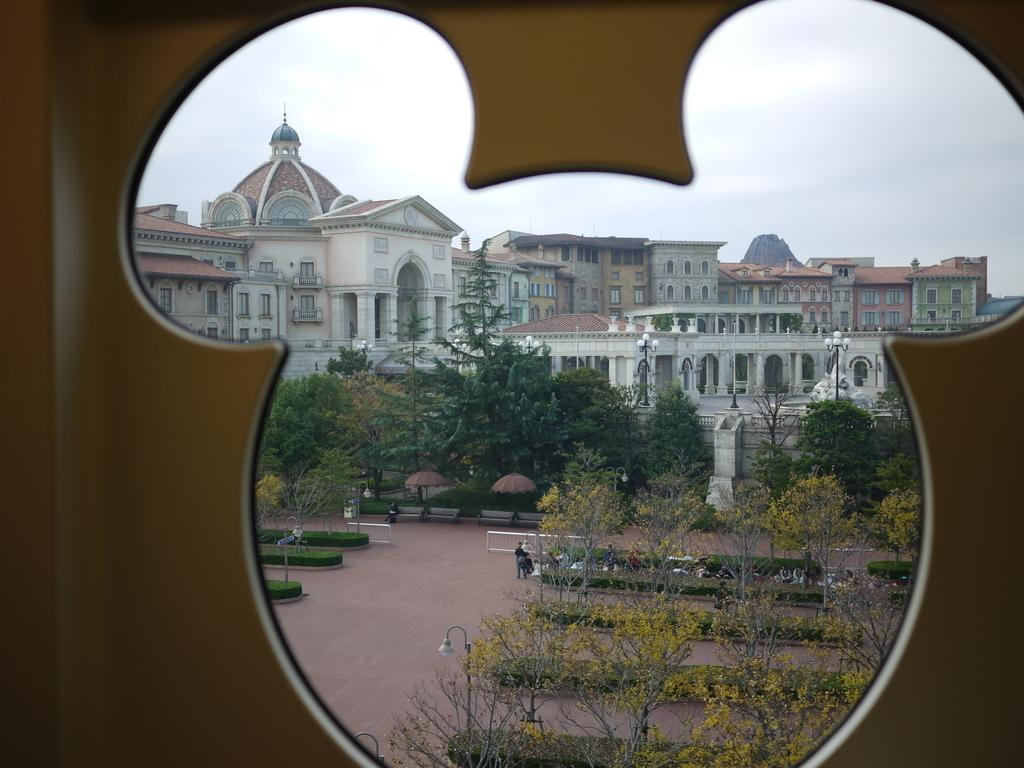What type of structures can be seen in the image? There are buildings in the image. What type of vegetation is present in the image? There are trees and bushes in the image. What type of street furniture can be seen in the image? There are lampposts in the image. What are the people in the image doing? There are people standing on the pavement and seated on benches in the image. How many trucks are parked in the image? There are no trucks present in the image. What is the level of disgust expressed by the people in the image? There is no indication of any emotion, including disgust, in the image. 